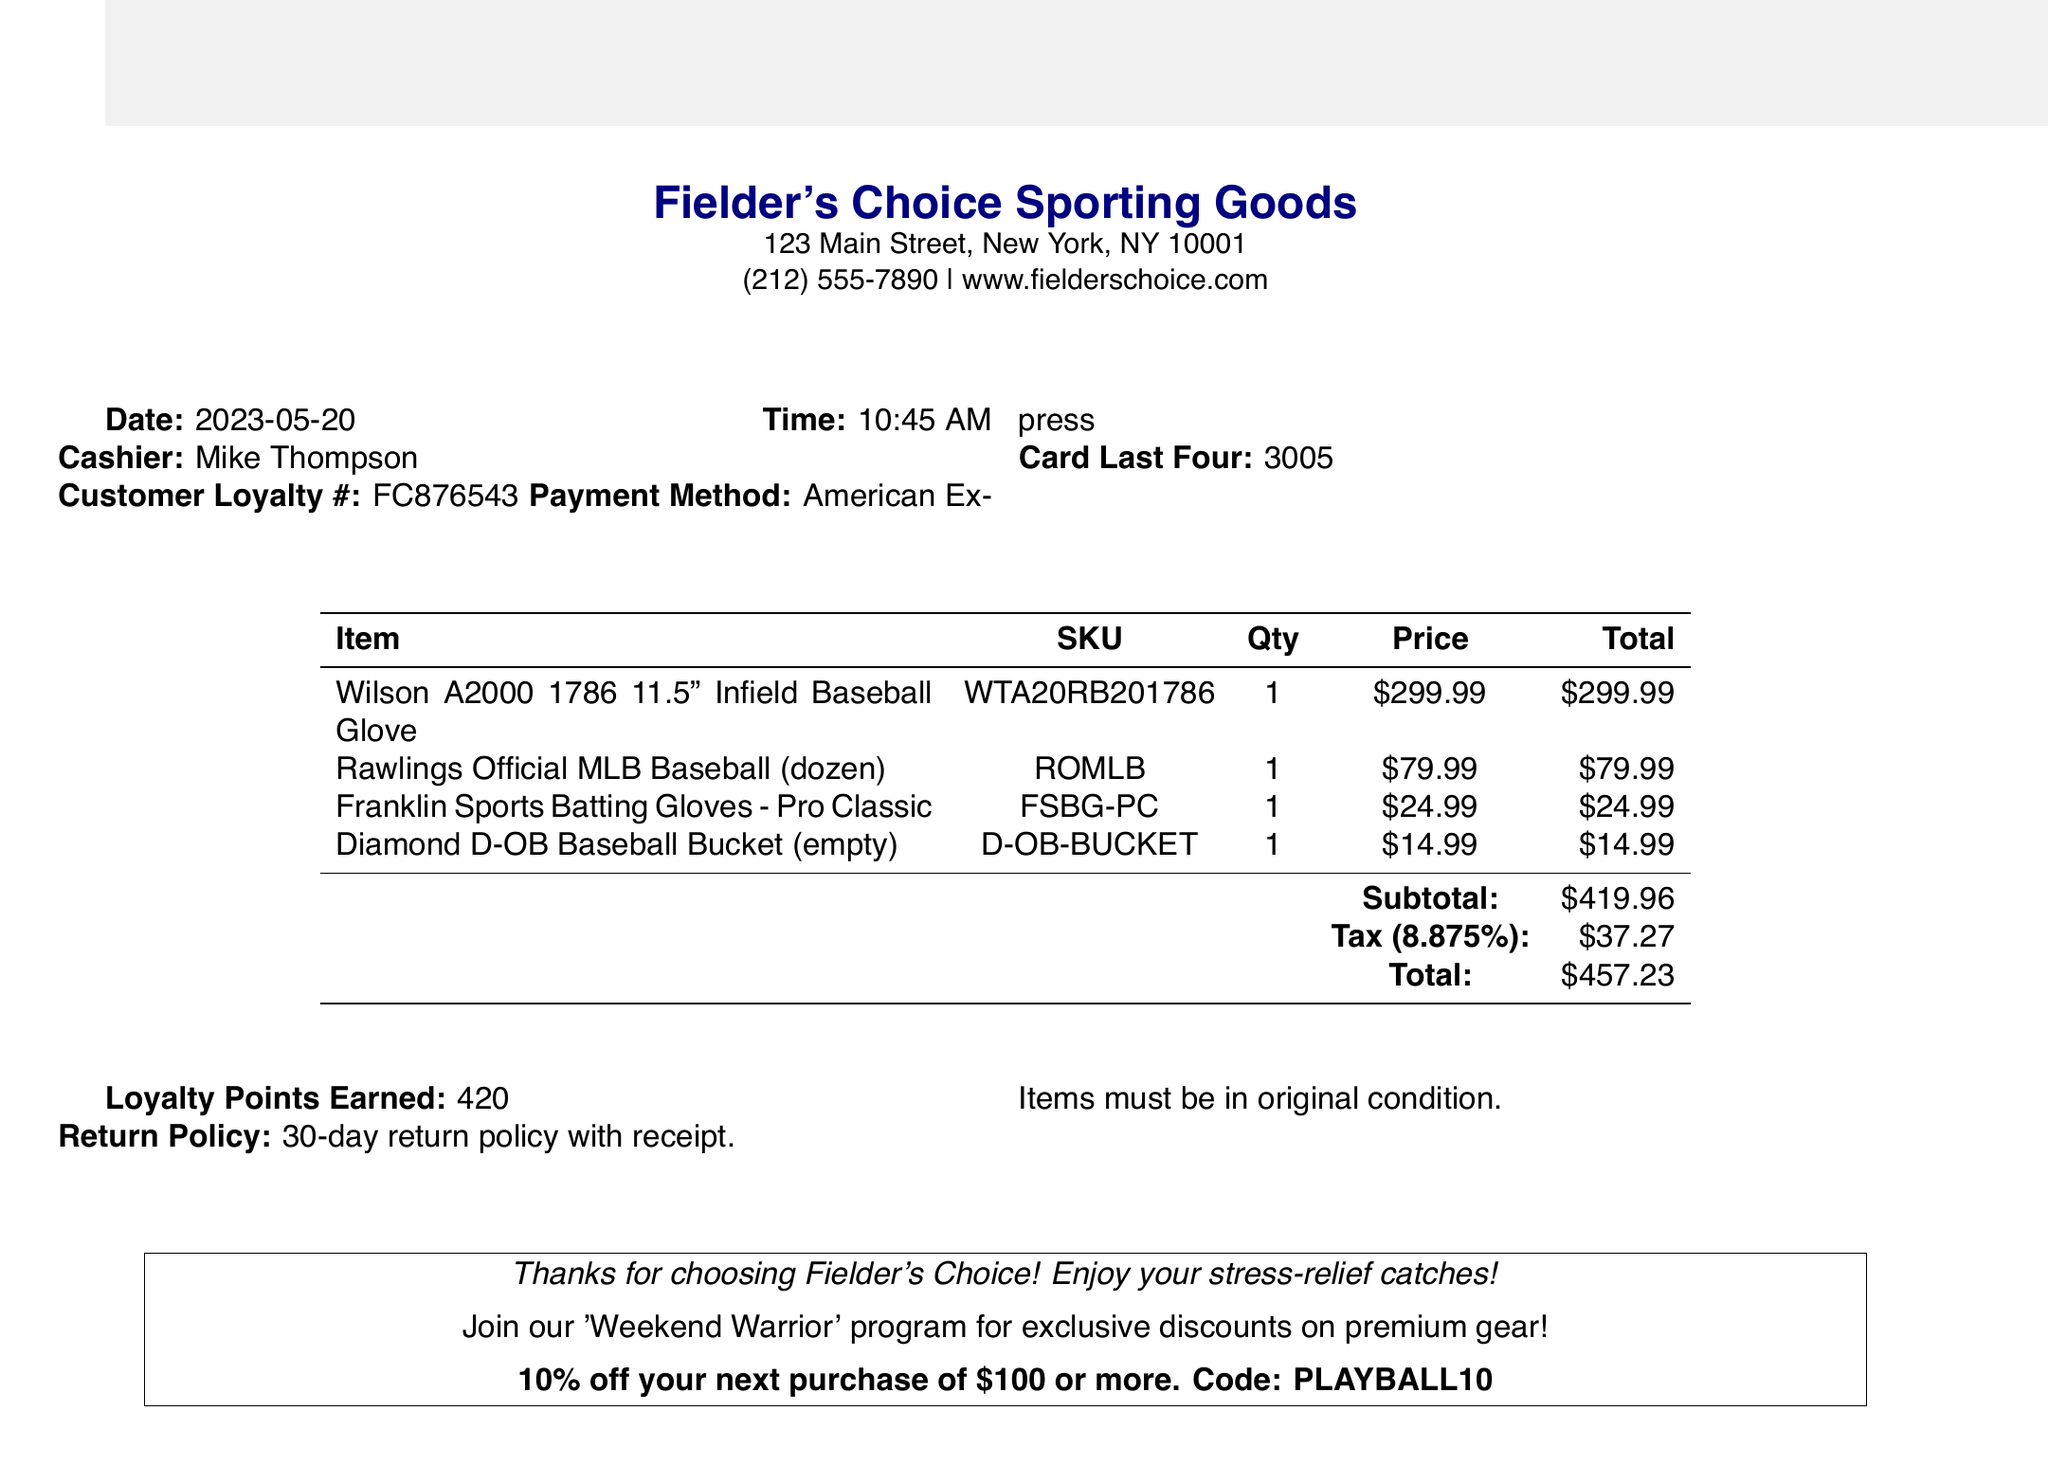What is the store name? The store name is listed at the top of the receipt.
Answer: Fielder's Choice Sporting Goods What was the purchase date? The purchase date is displayed near the beginning of the receipt.
Answer: 2023-05-20 How many Rawlings Official MLB Baseballs were purchased? The quantity of this item is shown in the item list.
Answer: 1 What is the tax amount? The tax amount is calculated and displayed towards the end of the receipt.
Answer: $37.27 What is the cashier's name? The cashier's name is provided in the transaction details section.
Answer: Mike Thompson What payment method was used? The payment method is shown under the payment details section of the receipt.
Answer: American Express How many loyalty points were earned? The loyalty points earned are listed in the document.
Answer: 420 What is the return policy? The return policy is explicitly mentioned in the document.
Answer: 30-day return policy with receipt What is the promotional offer mentioned? The promotional offer is included as part of the custom notes on the receipt.
Answer: Join our 'Weekend Warrior' program for exclusive discounts on premium gear! What is the total amount paid? The total amount is calculated and shown at the end of the document.
Answer: $457.23 